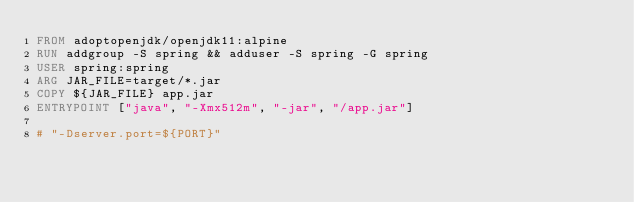Convert code to text. <code><loc_0><loc_0><loc_500><loc_500><_Dockerfile_>FROM adoptopenjdk/openjdk11:alpine
RUN addgroup -S spring && adduser -S spring -G spring
USER spring:spring
ARG JAR_FILE=target/*.jar
COPY ${JAR_FILE} app.jar
ENTRYPOINT ["java", "-Xmx512m", "-jar", "/app.jar"]

# "-Dserver.port=${PORT}"</code> 